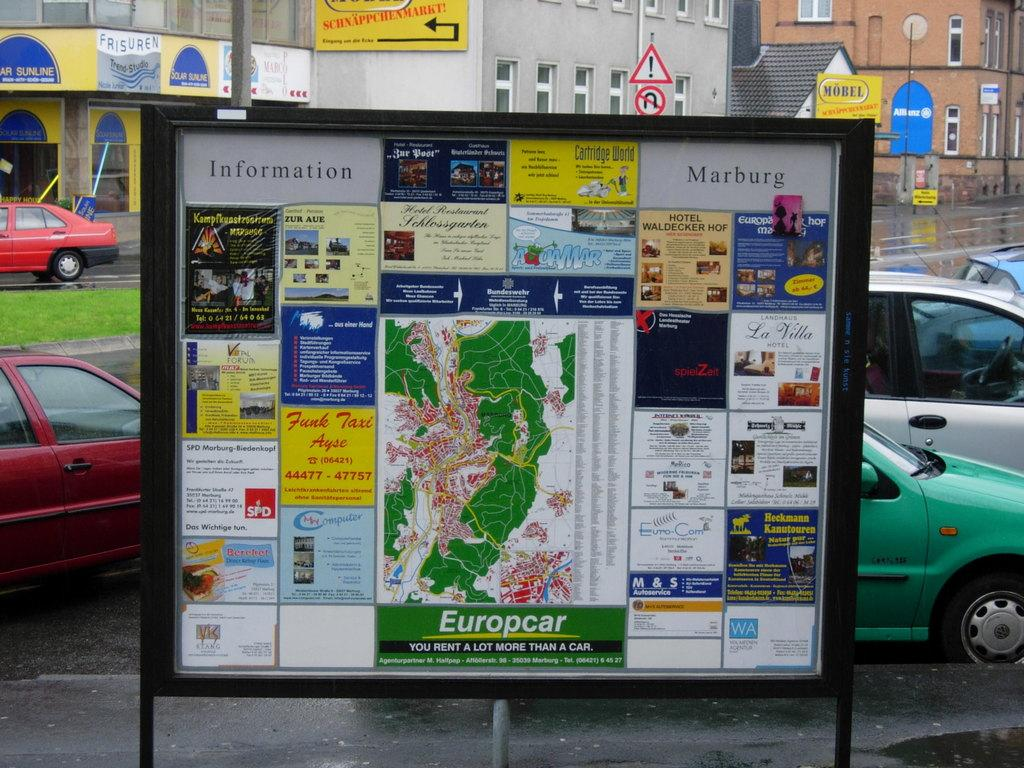<image>
Summarize the visual content of the image. a sign on a board that says Europcar on it 